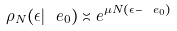<formula> <loc_0><loc_0><loc_500><loc_500>\rho _ { N } ( \epsilon | \ e _ { 0 } ) \asymp e ^ { \mu N ( \epsilon - \ e _ { 0 } ) }</formula> 